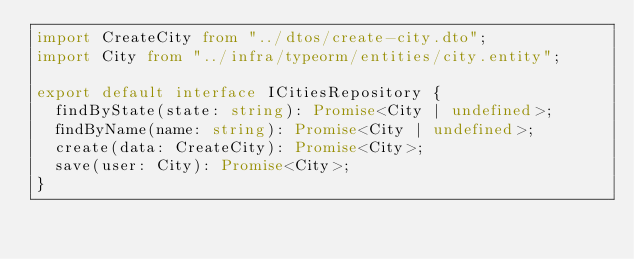<code> <loc_0><loc_0><loc_500><loc_500><_TypeScript_>import CreateCity from "../dtos/create-city.dto";
import City from "../infra/typeorm/entities/city.entity";

export default interface ICitiesRepository {
  findByState(state: string): Promise<City | undefined>;
  findByName(name: string): Promise<City | undefined>;
  create(data: CreateCity): Promise<City>;
  save(user: City): Promise<City>;
}
</code> 